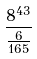<formula> <loc_0><loc_0><loc_500><loc_500>\frac { 8 ^ { 4 3 } } { \frac { 6 } { 1 6 5 } }</formula> 